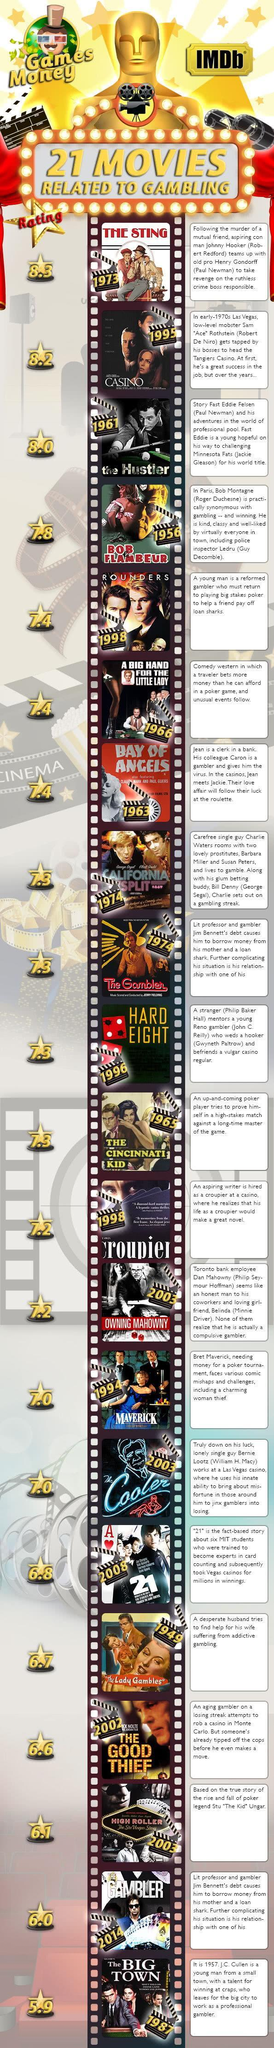In which years was the movie 'The Gambler' released?
Answer the question with a short phrase. 1974 In which years was the movie 'The Bay of Angels' released? 1963 What is the IMDB rating of the movie 'Hard Eight'? 7.3 Which is the least rated gambling movie as per IMDB? The Big Town In which years was the movie 'The Hustler' released? 1961 In which years was the movie 'The Sting' released? 1973 Which is the second most highest rated gambling movie as per IMDB? Casino In which year was the movie 'The Bay of Angels' released? 1963 What is the IMDB rating of the movie 'The Cincinnati Kid'? 7.3 Which is the highest rated gambling movie as per IMDB? The Sting 